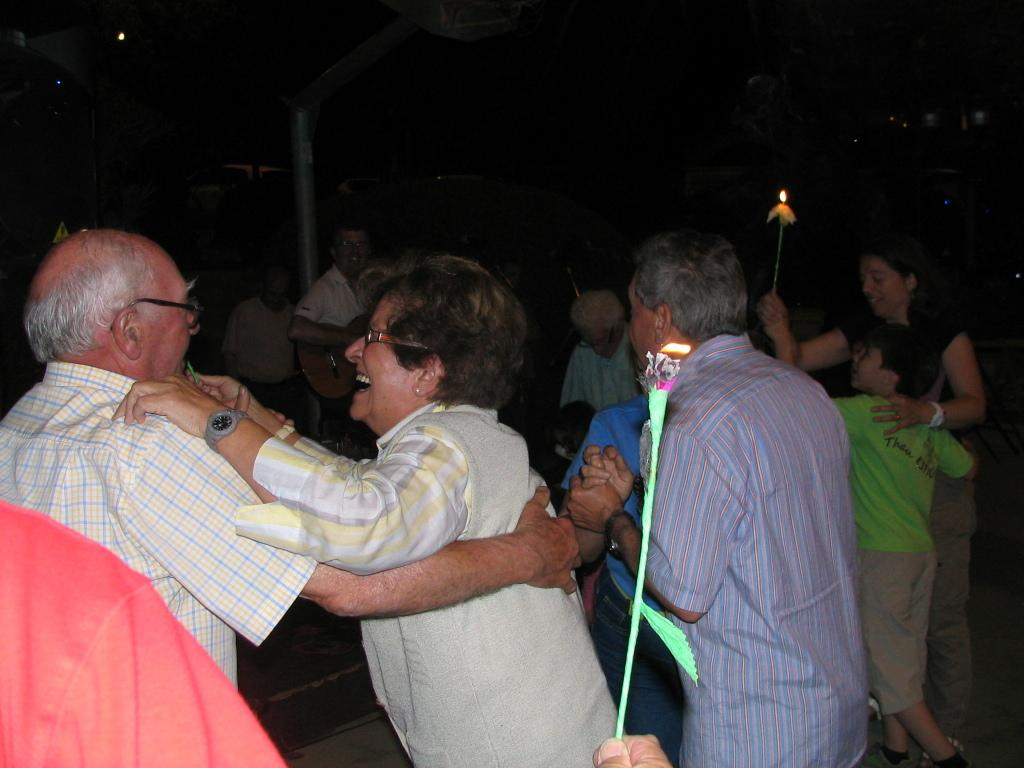How many people are in the image? There is a group of people in the image. What are some of the people doing in the image? Some of the people are holding fire with sticks. What type of worm can be seen crawling on the home in the image? There is no home or worm present in the image. 